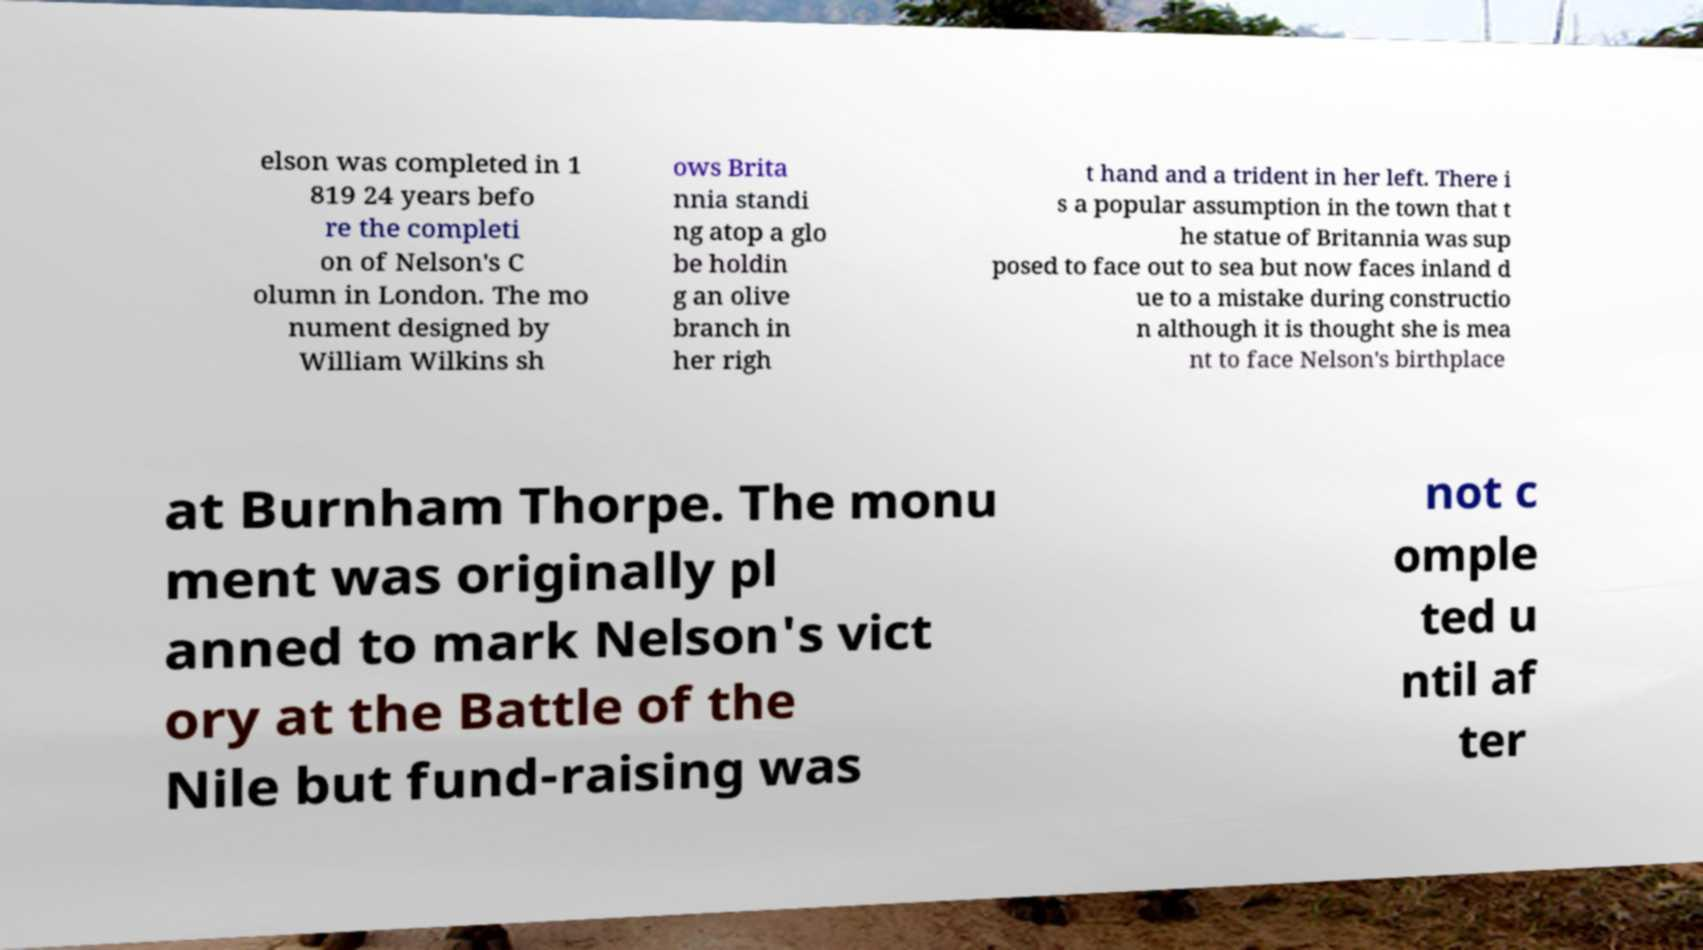Please identify and transcribe the text found in this image. elson was completed in 1 819 24 years befo re the completi on of Nelson's C olumn in London. The mo nument designed by William Wilkins sh ows Brita nnia standi ng atop a glo be holdin g an olive branch in her righ t hand and a trident in her left. There i s a popular assumption in the town that t he statue of Britannia was sup posed to face out to sea but now faces inland d ue to a mistake during constructio n although it is thought she is mea nt to face Nelson's birthplace at Burnham Thorpe. The monu ment was originally pl anned to mark Nelson's vict ory at the Battle of the Nile but fund-raising was not c omple ted u ntil af ter 